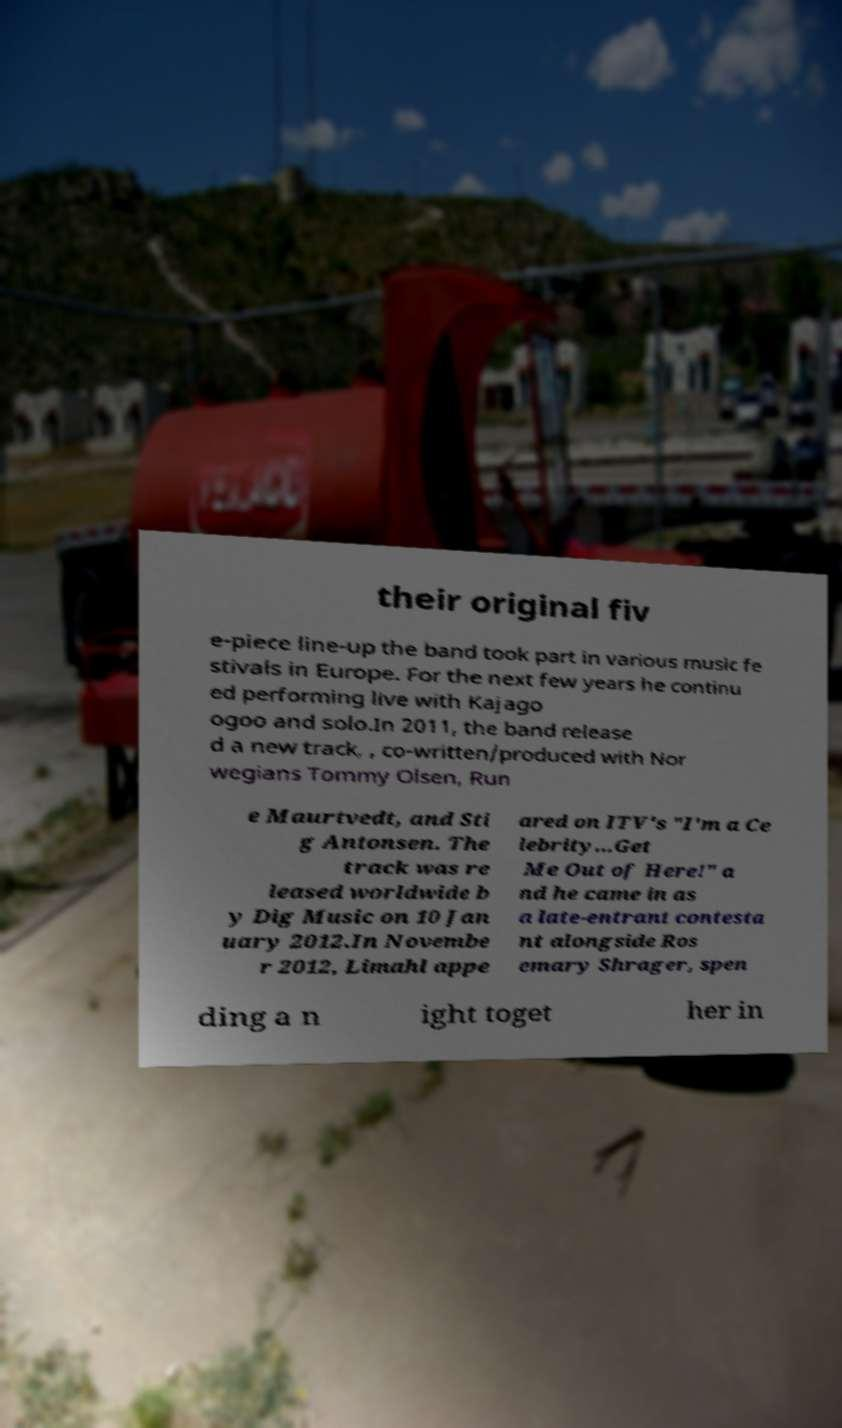Can you accurately transcribe the text from the provided image for me? their original fiv e-piece line-up the band took part in various music fe stivals in Europe. For the next few years he continu ed performing live with Kajago ogoo and solo.In 2011, the band release d a new track, , co-written/produced with Nor wegians Tommy Olsen, Run e Maurtvedt, and Sti g Antonsen. The track was re leased worldwide b y Dig Music on 10 Jan uary 2012.In Novembe r 2012, Limahl appe ared on ITV's "I'm a Ce lebrity...Get Me Out of Here!" a nd he came in as a late-entrant contesta nt alongside Ros emary Shrager, spen ding a n ight toget her in 